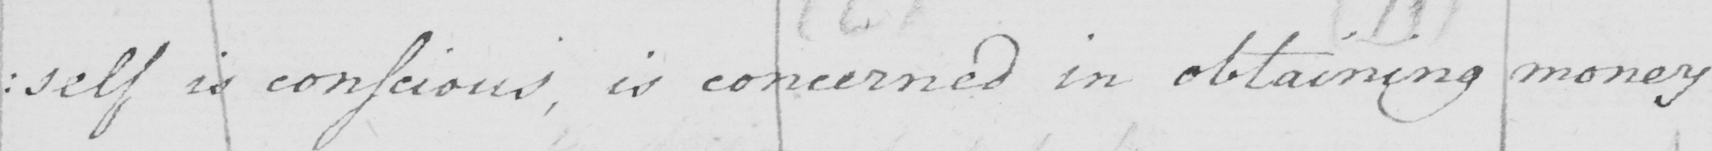What is written in this line of handwriting? : self is conscious , is concerned  in obtaining  money 